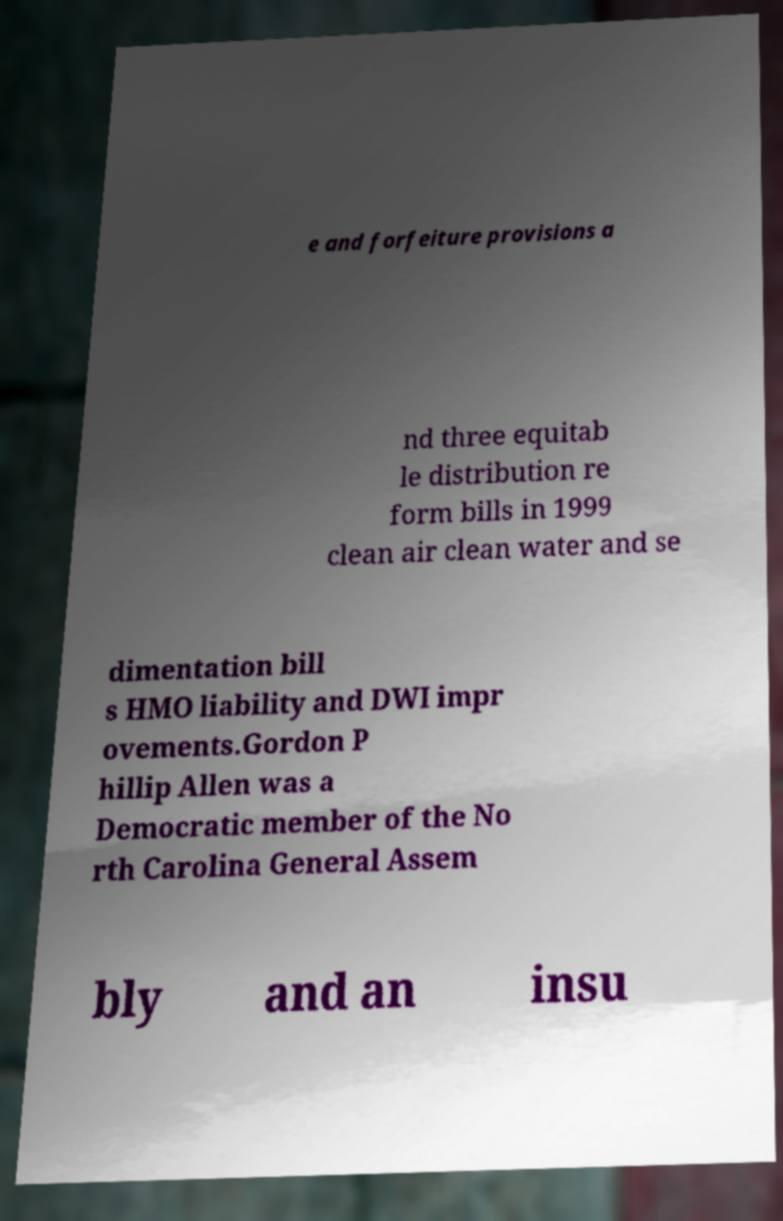I need the written content from this picture converted into text. Can you do that? e and forfeiture provisions a nd three equitab le distribution re form bills in 1999 clean air clean water and se dimentation bill s HMO liability and DWI impr ovements.Gordon P hillip Allen was a Democratic member of the No rth Carolina General Assem bly and an insu 